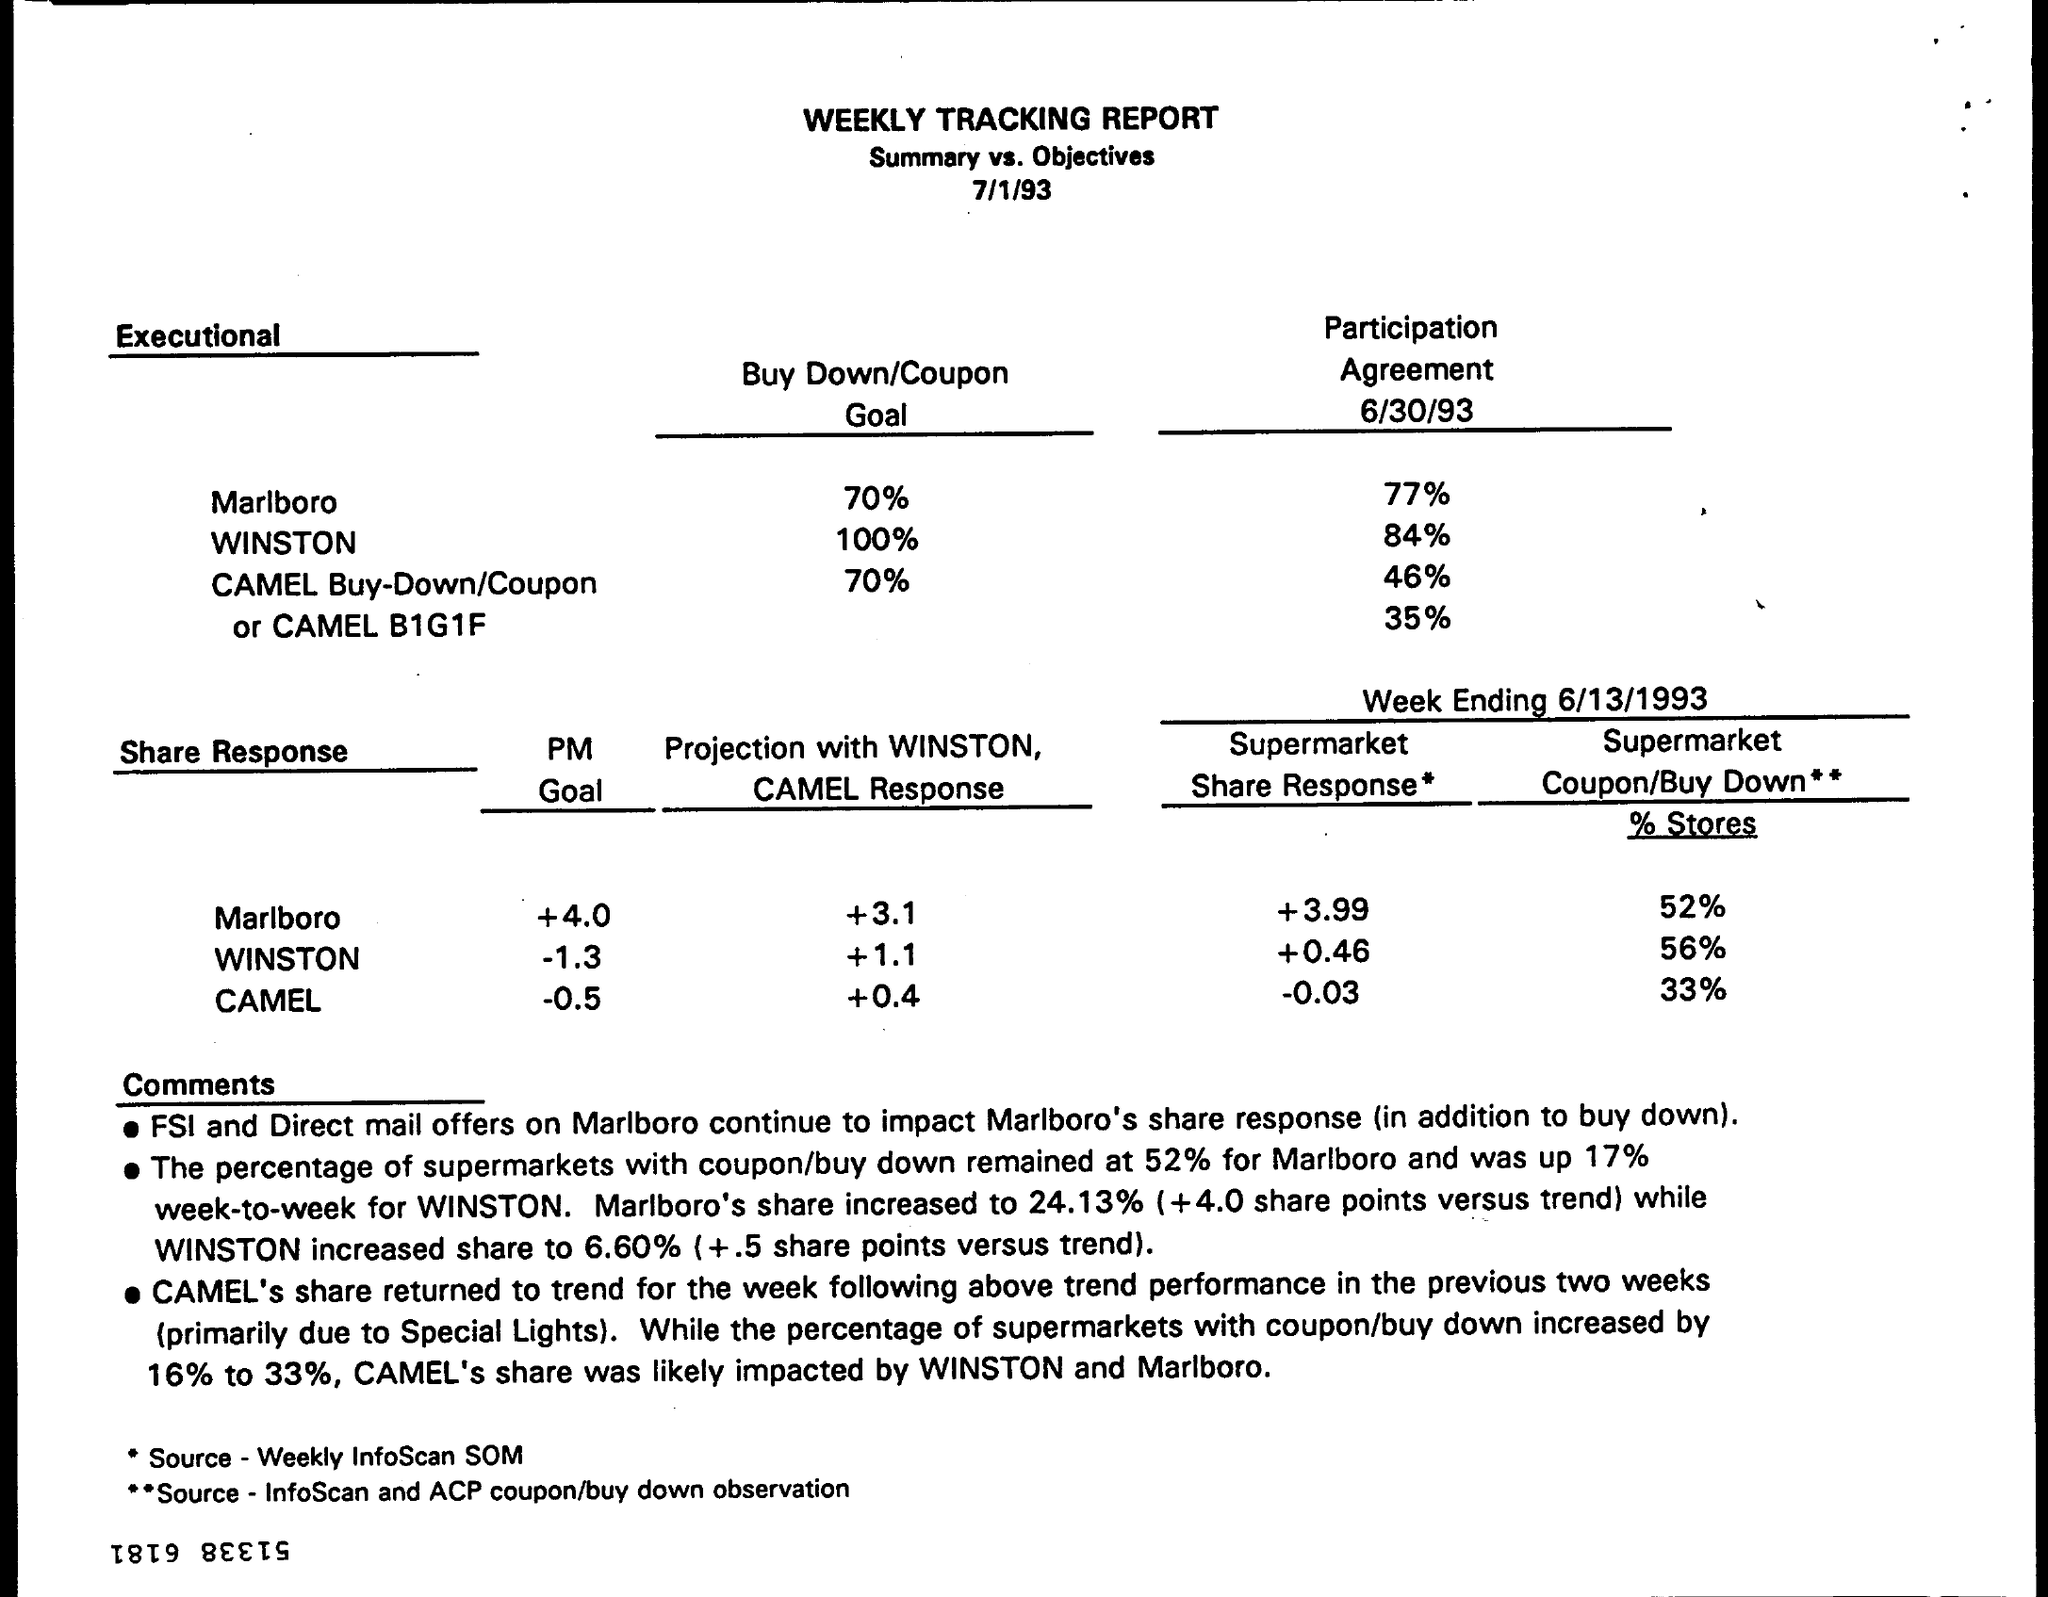List a handful of essential elements in this visual. The goal for Marlboro is to increase its PM score by 4.0 or more. The buy down or coupon goal for Camel is 70%. The PM Goal for Camel is to achieve a value between -0.5 and 0.5, inclusive. The buy-down/coupon goal for Winston is set at 100%. This document is titled 'WEEKLY TRACKING REPORT.' 